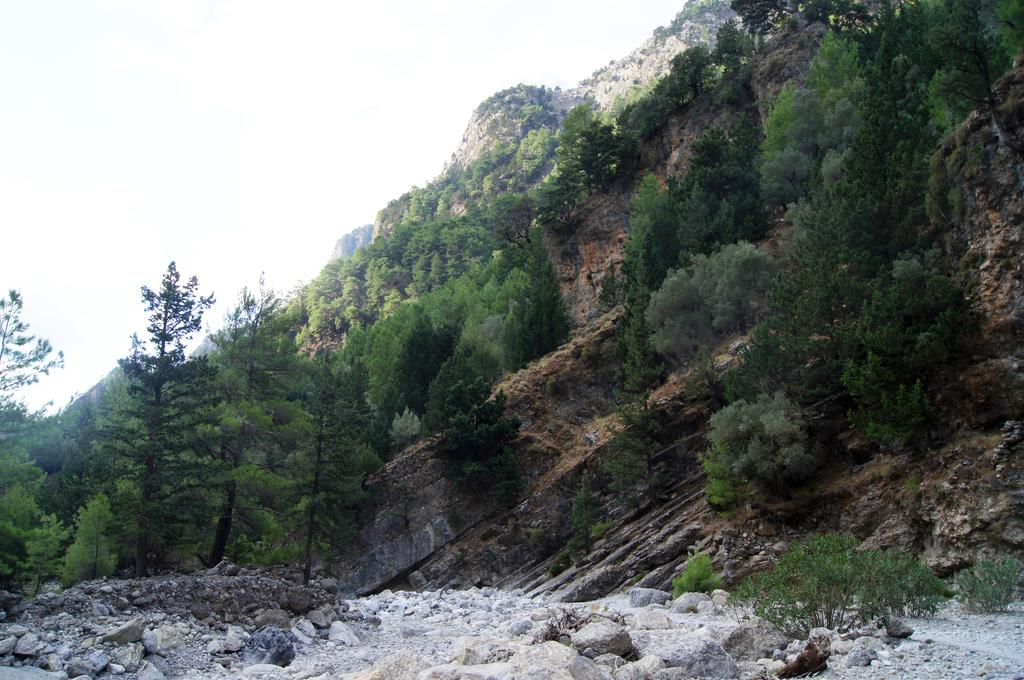What type of natural elements can be seen in the image? There are stones in the image. What can be seen in the background of the image? There are trees in the background of the image. What part of the natural environment is visible in the image? The sky is visible in the image. What type of smoke can be seen coming from the stones in the image? There is no smoke present in the image; it features stones, trees in the background, and the sky. 